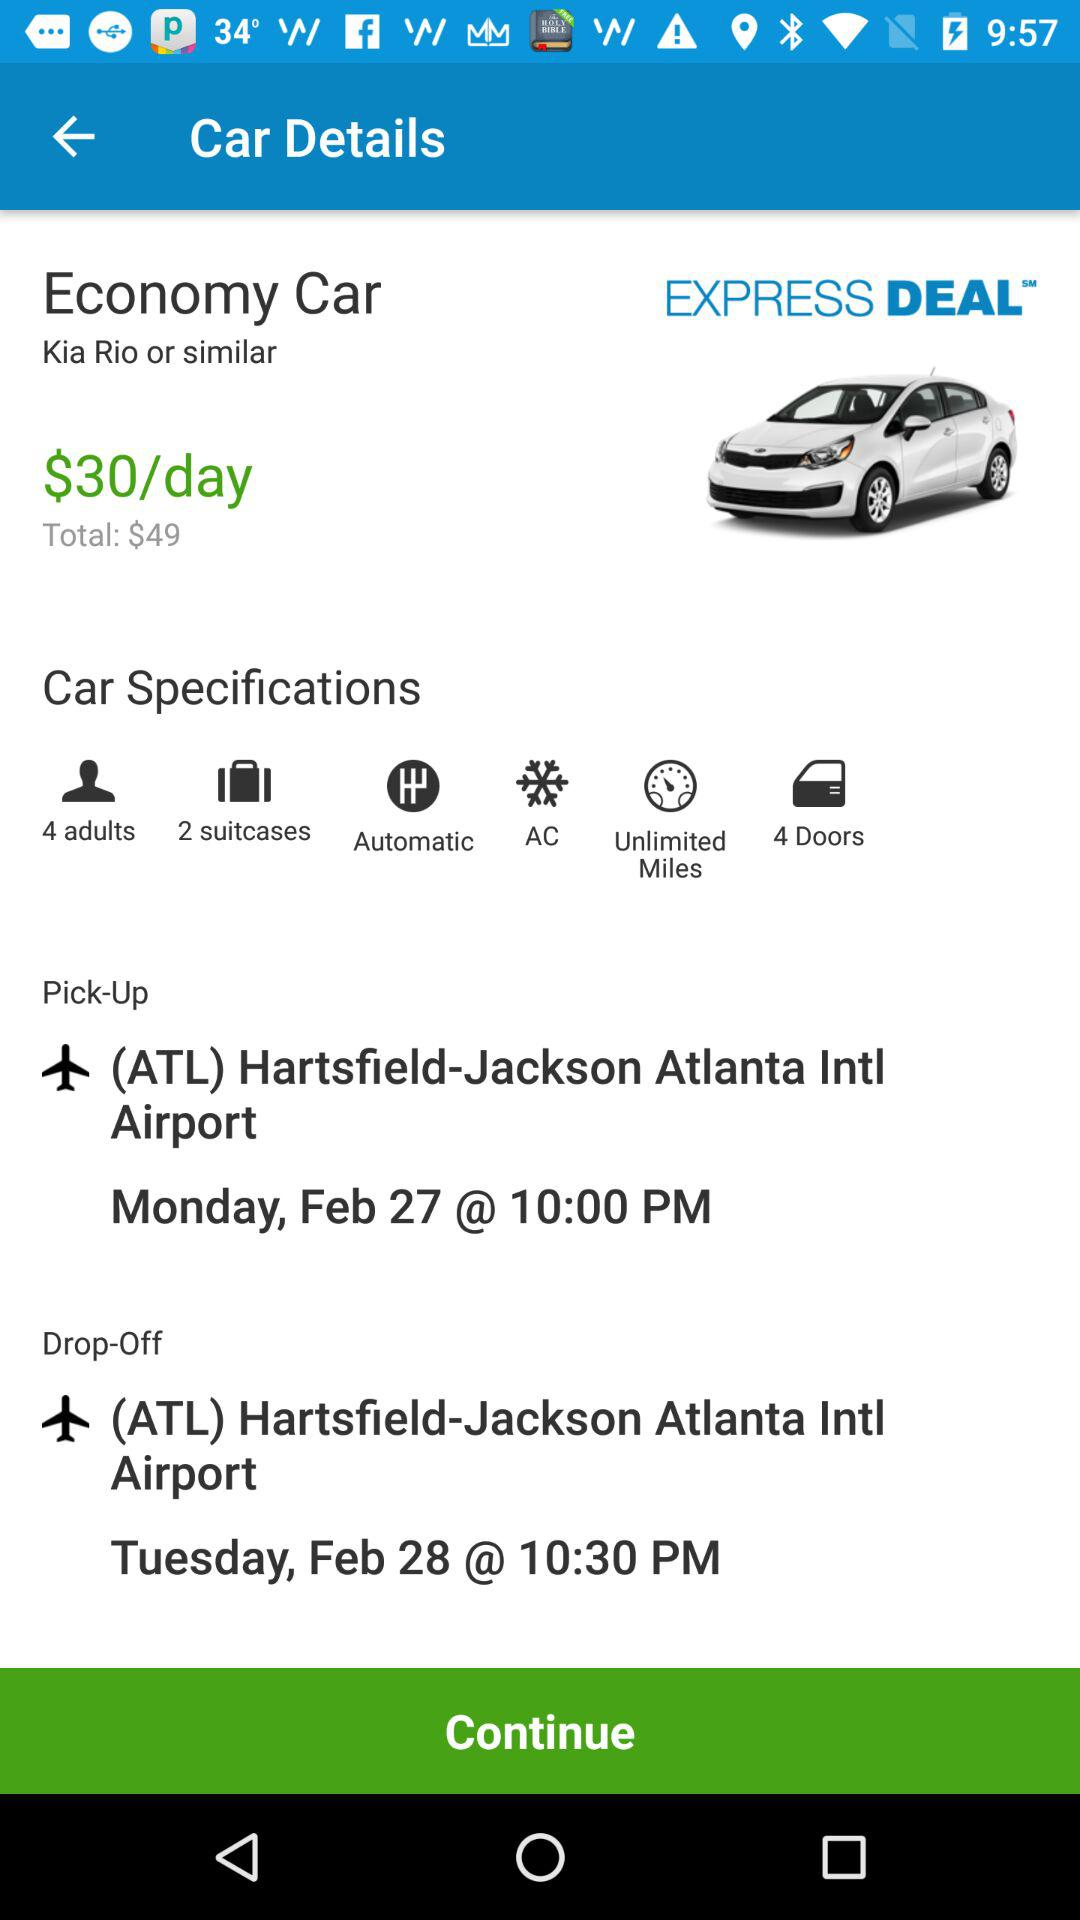What is the pick-up location? The pick-up location is (ATL) Hartsfield-Jackson Atlanta Intl Airport. 